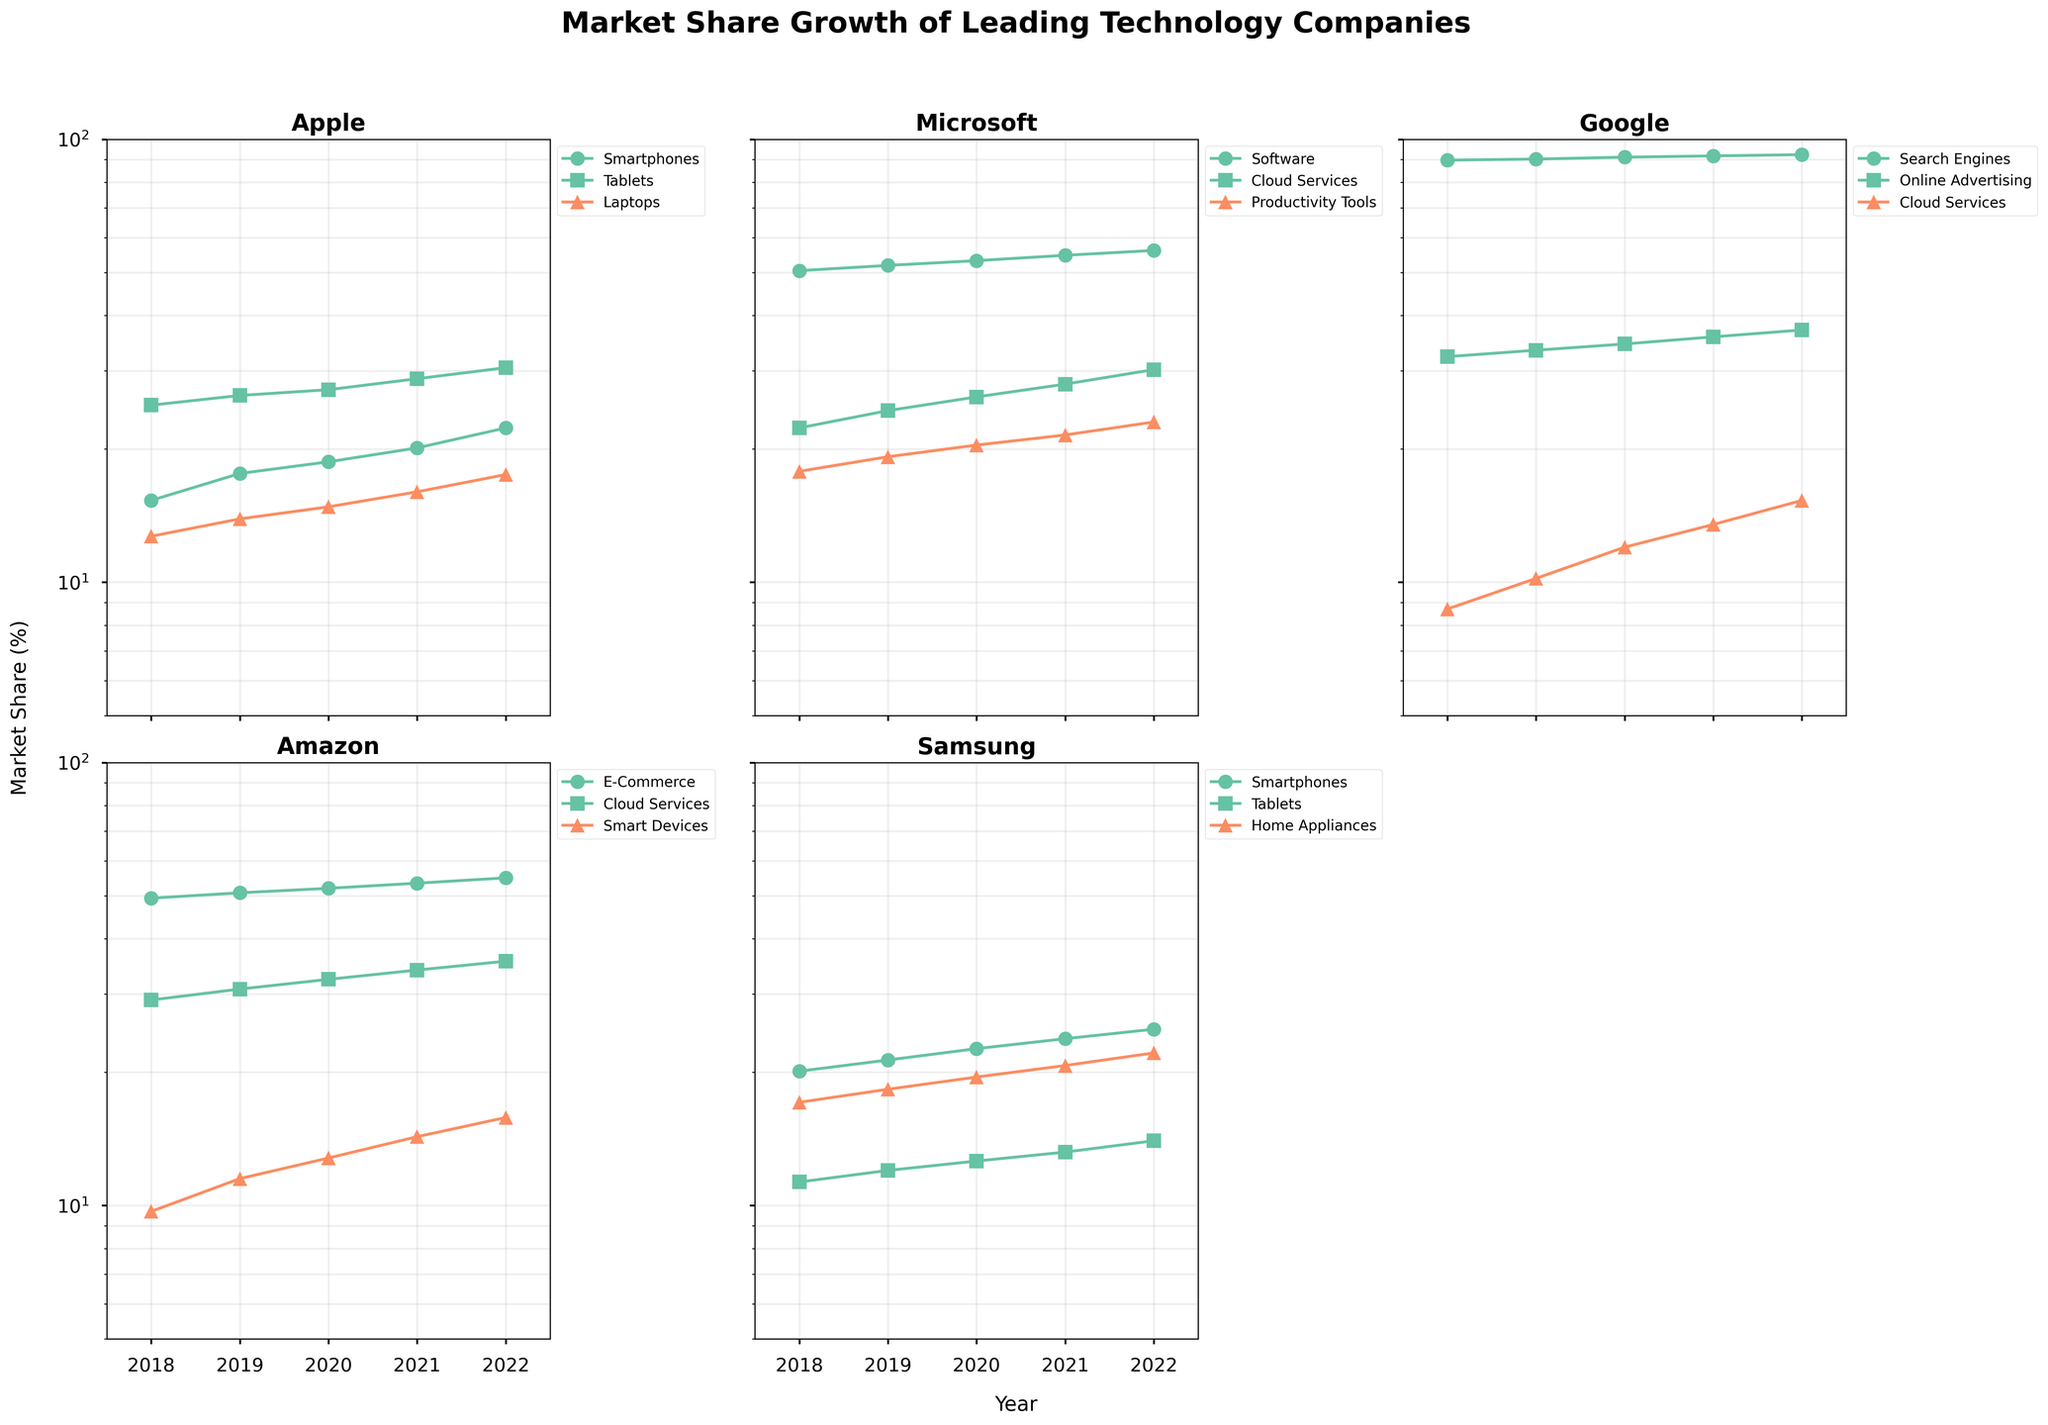What are the product categories tracked for Apple in the figure? Apple has three subplots corresponding to its product categories, which include Smartphones, Tablets, and Laptops.
Answer: Smartphones, Tablets, Laptops Which company's product category dominates the market share in Cloud Services in 2022? By examining the subplots, especially the Y-axis on a log scale, Microsoft's Cloud Services have the highest market share compared to those of Google and Amazon in 2022.
Answer: Microsoft How does Samsung's market share in Smartphones compare to that of Apple in 2022? Looking at the subplots for Apple and Samsung, Samsung's series for Smartphones is lower than Apple's in 2022, indicating that Apple has a higher market share for Smartphones.
Answer: Apple has higher market share What trend is observed in Google’s search engine market share across the years? In Google's subplot, the Search Engine market share remains very high and increases slightly from 2018 to 2022. This is noticeable as the data points are near the top of the range on a log scale.
Answer: Increasing slightly What is the difference in market share growth between Amazon's E-Commerce and Cloud Services from 2018 to 2022? In Amazon's subplot, E-Commerce starts at a higher market share than Cloud Services and both increase steadily. The difference in market share growth can be calculated by subtracting their respective values. The growth in E-Commerce is (54.9 - 49.4) = 5.5 and Cloud Services is (35.6 - 29.1) = 6.5. Thus, Cloud Services grew faster.
Answer: Cloud Services grew faster by 1.0 Which company's product category holds the highest consistent market share across the years? Analyzing the subplots, Google’s Search Engines consistently holds the highest market share across all years, consistently staying above 89% and increasing slightly.
Answer: Google’s Search Engines For Apple, how does the market share of Tablets in 2022 compare to its Laptops in 2020? Referring to Apple's subplot, Tablets have a market share of 30.5 in 2022, while Laptops have 14.8 in 2020. Clearly, Tablets have a much higher market share compared to Laptops two years earlier.
Answer: Tablets 2022 > Laptops 2020 Across all subplots, which product category shows the highest market share increase from 2018 to 2022? To find this, we need to compare the start and end values for all categories. Microsoft's Cloud Services increased from 22.3% to 30.2%, displaying a noticeable high increase, followed by Google’s Cloud Services from 8.7% to 15.3%. By comparing all categories, Google’s Cloud Services shows a substantial growth percentage-wise.
Answer: Google’s Cloud Services What year experiences the most significant overall market share increase for Apple’s product categories? Examining the annual increases in the Apple subplot, the most significant overall increases occur consistently over time, but notably from 2020 to 2021 show a significant rise in Smartphones, Tablets, and Laptops.
Answer: 2020 to 2021 Between Amazon and Samsung, which company's Smart Devices category grew more over the five years? Amazon's Smart Devices grew from 9.7 to 15.8, and Samsung’s comparable category, likely Home Appliances (though not strictly smart), grew from 17.1 to 22.1. Calculating growth, Amazon’s growth (15.8 - 9.7 = 6.1), and Samsung’s (22.1 - 17.1 = 5.0) means Amazon grew more.
Answer: Amazon 